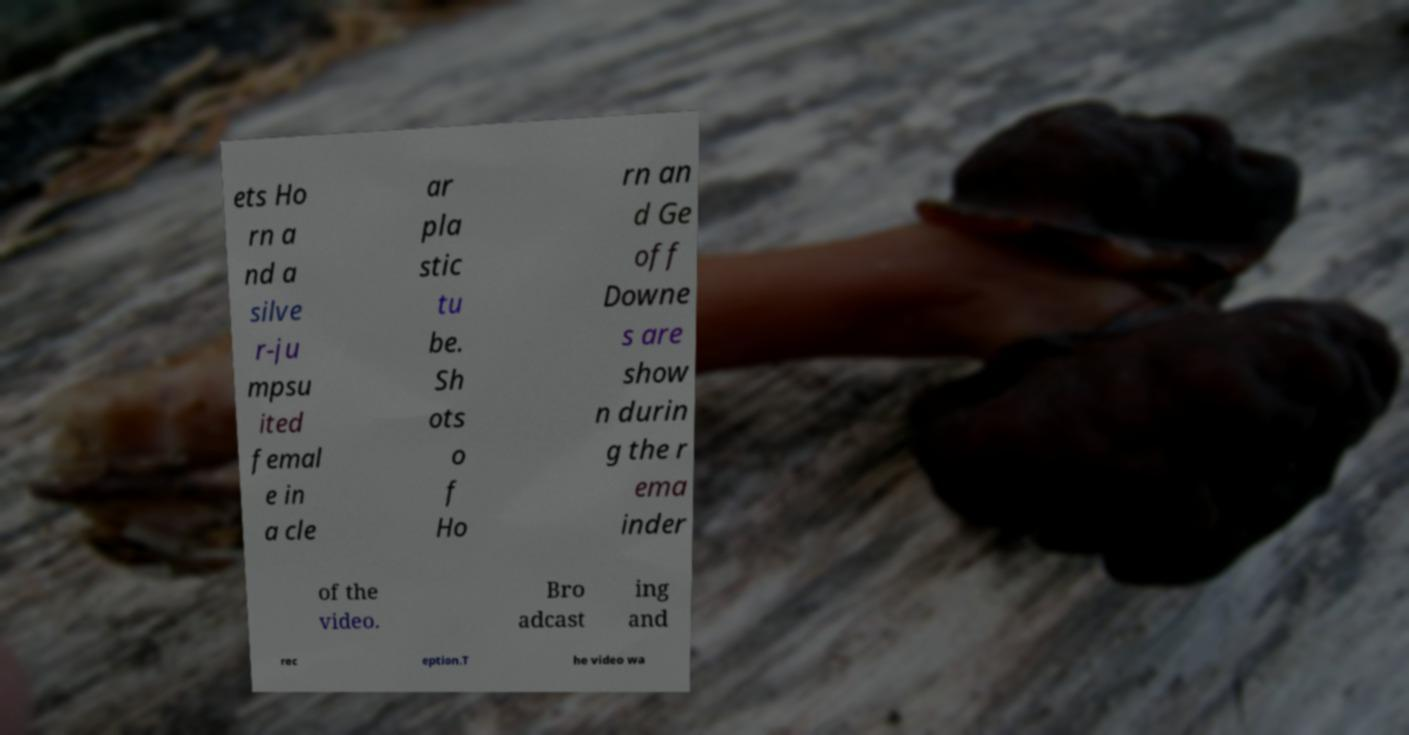Please identify and transcribe the text found in this image. ets Ho rn a nd a silve r-ju mpsu ited femal e in a cle ar pla stic tu be. Sh ots o f Ho rn an d Ge off Downe s are show n durin g the r ema inder of the video. Bro adcast ing and rec eption.T he video wa 